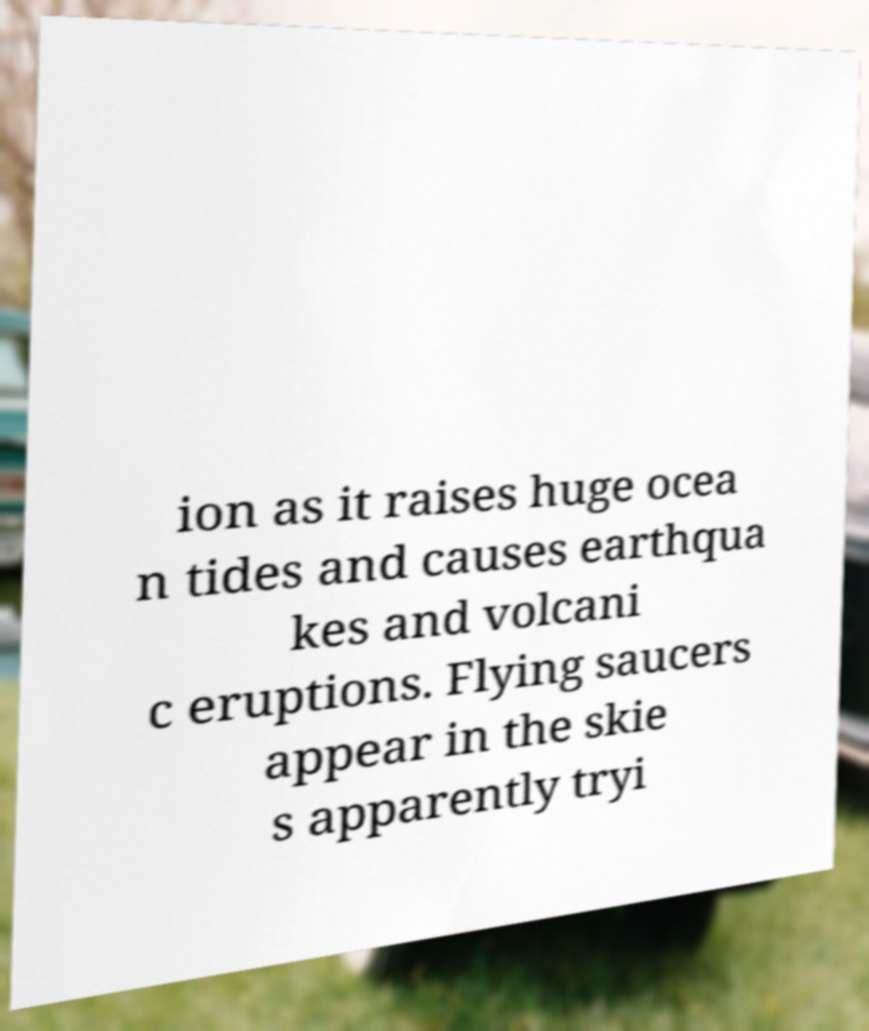Can you read and provide the text displayed in the image?This photo seems to have some interesting text. Can you extract and type it out for me? ion as it raises huge ocea n tides and causes earthqua kes and volcani c eruptions. Flying saucers appear in the skie s apparently tryi 